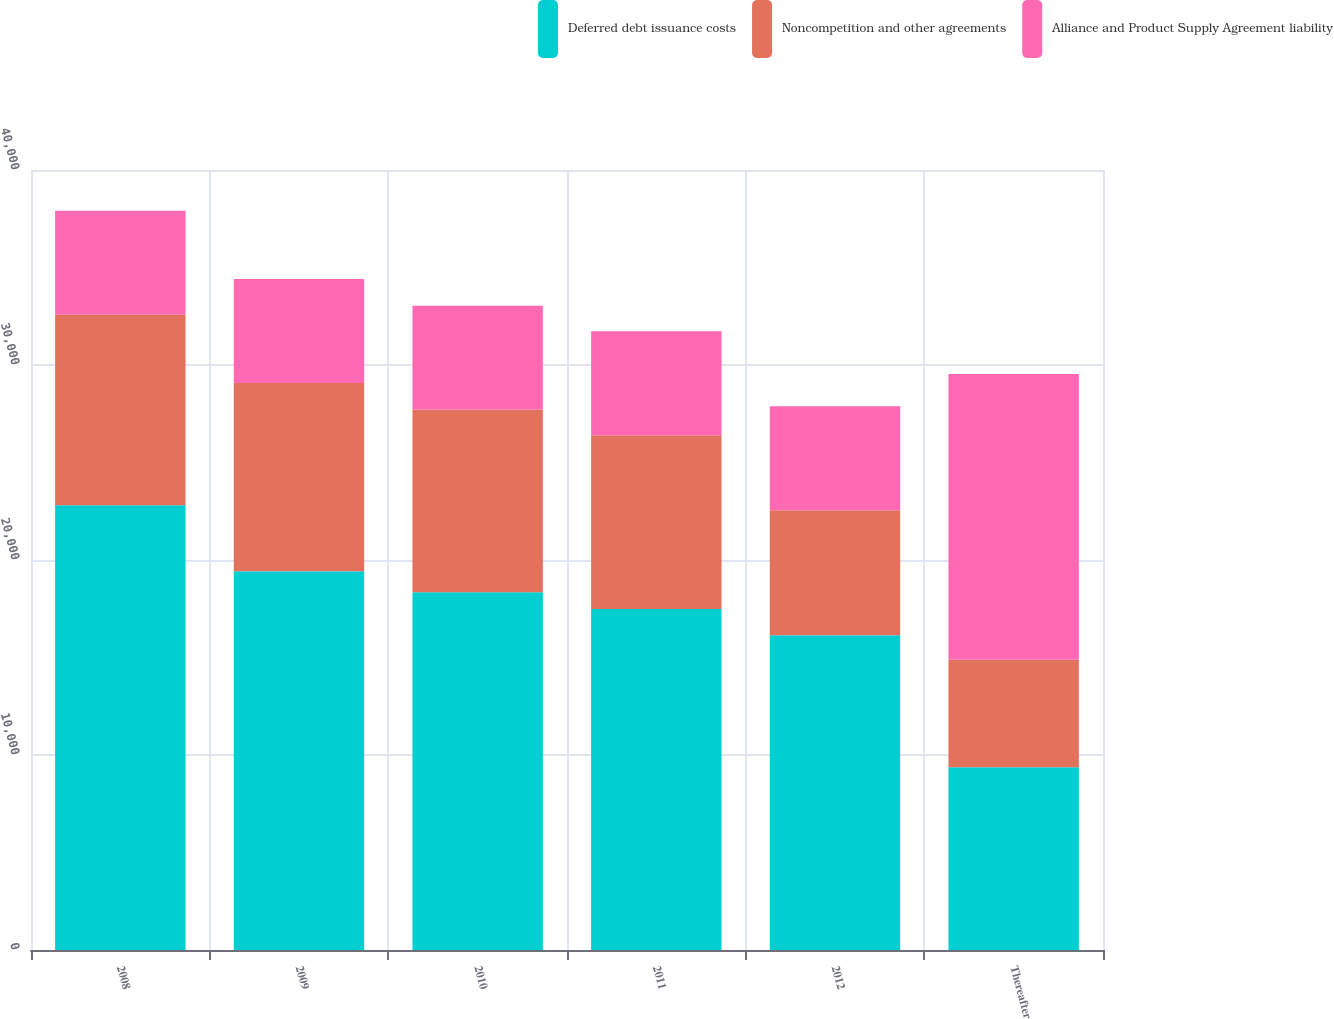Convert chart. <chart><loc_0><loc_0><loc_500><loc_500><stacked_bar_chart><ecel><fcel>2008<fcel>2009<fcel>2010<fcel>2011<fcel>2012<fcel>Thereafter<nl><fcel>Deferred debt issuance costs<fcel>22808<fcel>19428<fcel>18340<fcel>17488<fcel>16138<fcel>9374<nl><fcel>Noncompetition and other agreements<fcel>9772<fcel>9646<fcel>9374<fcel>8914<fcel>6418<fcel>5510<nl><fcel>Alliance and Product Supply Agreement liability<fcel>5330<fcel>5330<fcel>5330<fcel>5330<fcel>5330<fcel>14657<nl></chart> 